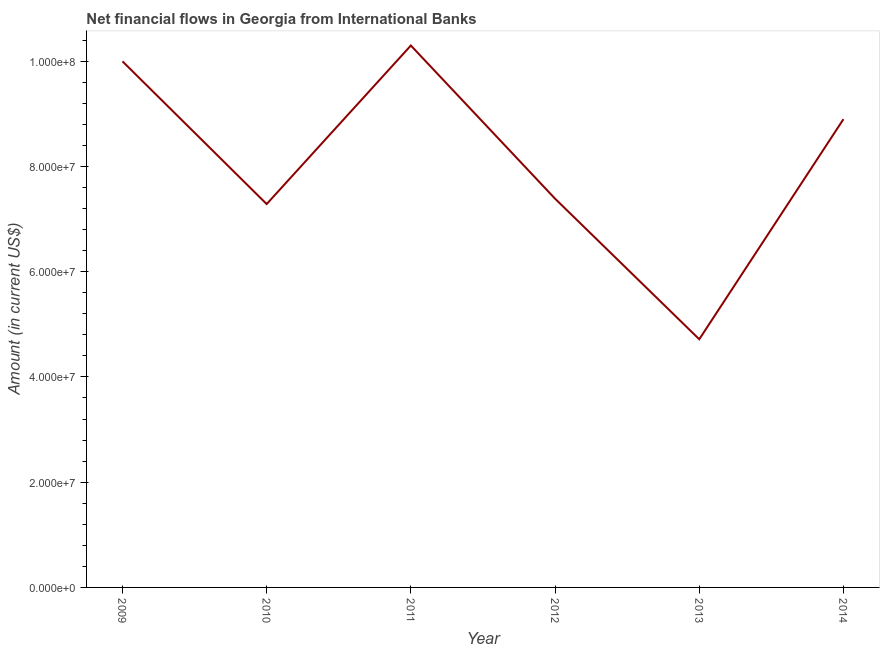What is the net financial flows from ibrd in 2012?
Make the answer very short. 7.39e+07. Across all years, what is the maximum net financial flows from ibrd?
Your answer should be very brief. 1.03e+08. Across all years, what is the minimum net financial flows from ibrd?
Give a very brief answer. 4.72e+07. In which year was the net financial flows from ibrd maximum?
Provide a short and direct response. 2011. In which year was the net financial flows from ibrd minimum?
Your answer should be compact. 2013. What is the sum of the net financial flows from ibrd?
Offer a very short reply. 4.86e+08. What is the difference between the net financial flows from ibrd in 2013 and 2014?
Keep it short and to the point. -4.18e+07. What is the average net financial flows from ibrd per year?
Make the answer very short. 8.10e+07. What is the median net financial flows from ibrd?
Your response must be concise. 8.14e+07. Do a majority of the years between 2009 and 2012 (inclusive) have net financial flows from ibrd greater than 88000000 US$?
Offer a terse response. No. What is the ratio of the net financial flows from ibrd in 2013 to that in 2014?
Your answer should be very brief. 0.53. Is the net financial flows from ibrd in 2010 less than that in 2014?
Give a very brief answer. Yes. Is the difference between the net financial flows from ibrd in 2009 and 2011 greater than the difference between any two years?
Ensure brevity in your answer.  No. What is the difference between the highest and the second highest net financial flows from ibrd?
Offer a very short reply. 3.01e+06. Is the sum of the net financial flows from ibrd in 2009 and 2013 greater than the maximum net financial flows from ibrd across all years?
Give a very brief answer. Yes. What is the difference between the highest and the lowest net financial flows from ibrd?
Your response must be concise. 5.58e+07. In how many years, is the net financial flows from ibrd greater than the average net financial flows from ibrd taken over all years?
Your answer should be very brief. 3. How many lines are there?
Keep it short and to the point. 1. How many years are there in the graph?
Provide a short and direct response. 6. Does the graph contain any zero values?
Ensure brevity in your answer.  No. What is the title of the graph?
Offer a terse response. Net financial flows in Georgia from International Banks. What is the Amount (in current US$) of 2009?
Your answer should be compact. 1.00e+08. What is the Amount (in current US$) of 2010?
Provide a short and direct response. 7.28e+07. What is the Amount (in current US$) of 2011?
Give a very brief answer. 1.03e+08. What is the Amount (in current US$) in 2012?
Provide a short and direct response. 7.39e+07. What is the Amount (in current US$) of 2013?
Offer a very short reply. 4.72e+07. What is the Amount (in current US$) of 2014?
Give a very brief answer. 8.90e+07. What is the difference between the Amount (in current US$) in 2009 and 2010?
Offer a very short reply. 2.71e+07. What is the difference between the Amount (in current US$) in 2009 and 2011?
Your answer should be very brief. -3.01e+06. What is the difference between the Amount (in current US$) in 2009 and 2012?
Provide a succinct answer. 2.61e+07. What is the difference between the Amount (in current US$) in 2009 and 2013?
Your response must be concise. 5.28e+07. What is the difference between the Amount (in current US$) in 2009 and 2014?
Keep it short and to the point. 1.10e+07. What is the difference between the Amount (in current US$) in 2010 and 2011?
Your answer should be very brief. -3.01e+07. What is the difference between the Amount (in current US$) in 2010 and 2012?
Your response must be concise. -1.02e+06. What is the difference between the Amount (in current US$) in 2010 and 2013?
Give a very brief answer. 2.57e+07. What is the difference between the Amount (in current US$) in 2010 and 2014?
Give a very brief answer. -1.61e+07. What is the difference between the Amount (in current US$) in 2011 and 2012?
Provide a short and direct response. 2.91e+07. What is the difference between the Amount (in current US$) in 2011 and 2013?
Provide a short and direct response. 5.58e+07. What is the difference between the Amount (in current US$) in 2011 and 2014?
Ensure brevity in your answer.  1.40e+07. What is the difference between the Amount (in current US$) in 2012 and 2013?
Ensure brevity in your answer.  2.67e+07. What is the difference between the Amount (in current US$) in 2012 and 2014?
Your answer should be very brief. -1.51e+07. What is the difference between the Amount (in current US$) in 2013 and 2014?
Keep it short and to the point. -4.18e+07. What is the ratio of the Amount (in current US$) in 2009 to that in 2010?
Your response must be concise. 1.37. What is the ratio of the Amount (in current US$) in 2009 to that in 2011?
Your answer should be very brief. 0.97. What is the ratio of the Amount (in current US$) in 2009 to that in 2012?
Make the answer very short. 1.35. What is the ratio of the Amount (in current US$) in 2009 to that in 2013?
Offer a terse response. 2.12. What is the ratio of the Amount (in current US$) in 2009 to that in 2014?
Your answer should be very brief. 1.12. What is the ratio of the Amount (in current US$) in 2010 to that in 2011?
Provide a short and direct response. 0.71. What is the ratio of the Amount (in current US$) in 2010 to that in 2012?
Offer a very short reply. 0.99. What is the ratio of the Amount (in current US$) in 2010 to that in 2013?
Give a very brief answer. 1.54. What is the ratio of the Amount (in current US$) in 2010 to that in 2014?
Provide a short and direct response. 0.82. What is the ratio of the Amount (in current US$) in 2011 to that in 2012?
Your answer should be very brief. 1.39. What is the ratio of the Amount (in current US$) in 2011 to that in 2013?
Offer a very short reply. 2.18. What is the ratio of the Amount (in current US$) in 2011 to that in 2014?
Give a very brief answer. 1.16. What is the ratio of the Amount (in current US$) in 2012 to that in 2013?
Your answer should be very brief. 1.57. What is the ratio of the Amount (in current US$) in 2012 to that in 2014?
Keep it short and to the point. 0.83. What is the ratio of the Amount (in current US$) in 2013 to that in 2014?
Make the answer very short. 0.53. 